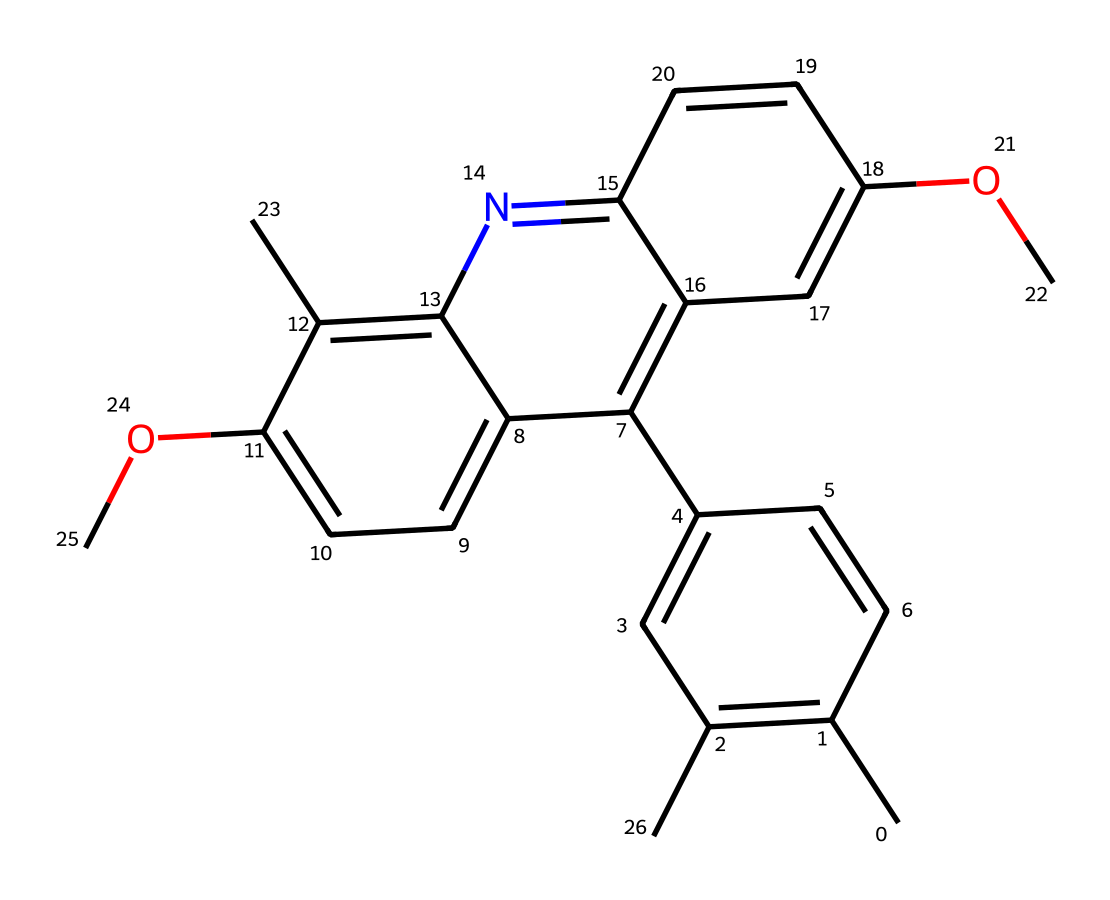How many rings are in this chemical structure? The chemical structure contains several fused aromatic rings, which are indicated by the multiple interconnected cycles in the visual representation. Counting these fused cycles reveals there are five distinct rings in total.
Answer: five What functional group is present in this chemical? The structure shows two –O– (ether) linkages, represented by the oxygen atoms connected to carbon atoms, indicating the presence of ether functional groups.
Answer: ether What is the overall color change behavior of this chemical when exposed to UV light? Photoreactive chemicals often undergo structural changes or isomerization upon UV exposure. This chemical, being photochromic, typically transitions from a clear or lighter shade to a darker or colored form when exposed to UV light, characteristic of photochromic behavior.
Answer: darkens How many carbon atoms are present in this chemical? A careful examination of the structure counting all the carbon atoms, including those that are part of the aromatic rings and side chains, results in a total of 28 carbon atoms being present in this compound.
Answer: 28 What type of light triggers the reaction in this chemical? Photoreactive chemicals are specifically designed to react to ultraviolet light, which triggers the isomerization process in photochromic materials, resulting in the color change seen in photochromic lenses.
Answer: ultraviolet What type of chemical behavior does this structure exhibit upon exposure to light? This compound exhibits photoisomerization, which means it can change its structure—typically leading to a reversible transition between two states—when exposed to light, most commonly UV light.
Answer: photoisomerization 